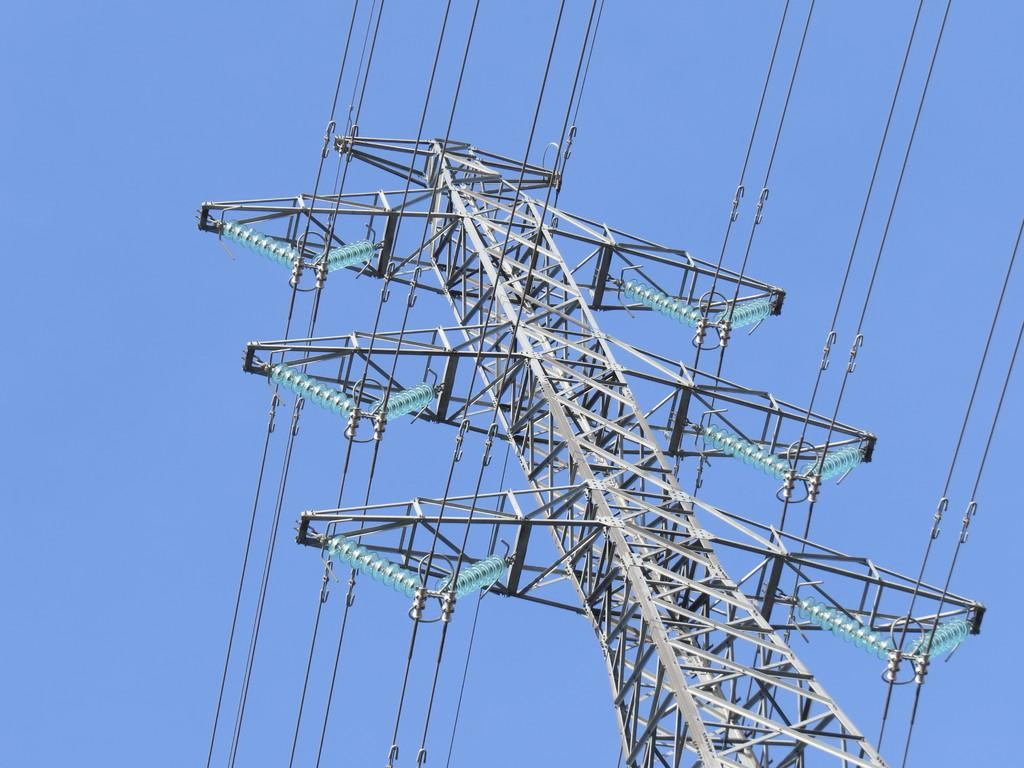What is the main subject in the center of the image? There is an electrical tower with wires in the center of the image. What can be seen in the background of the image? The background of the image includes the sky. What type of tooth is visible in the image? There is no tooth present in the image; it features an electrical tower with wires and the sky in the background. 